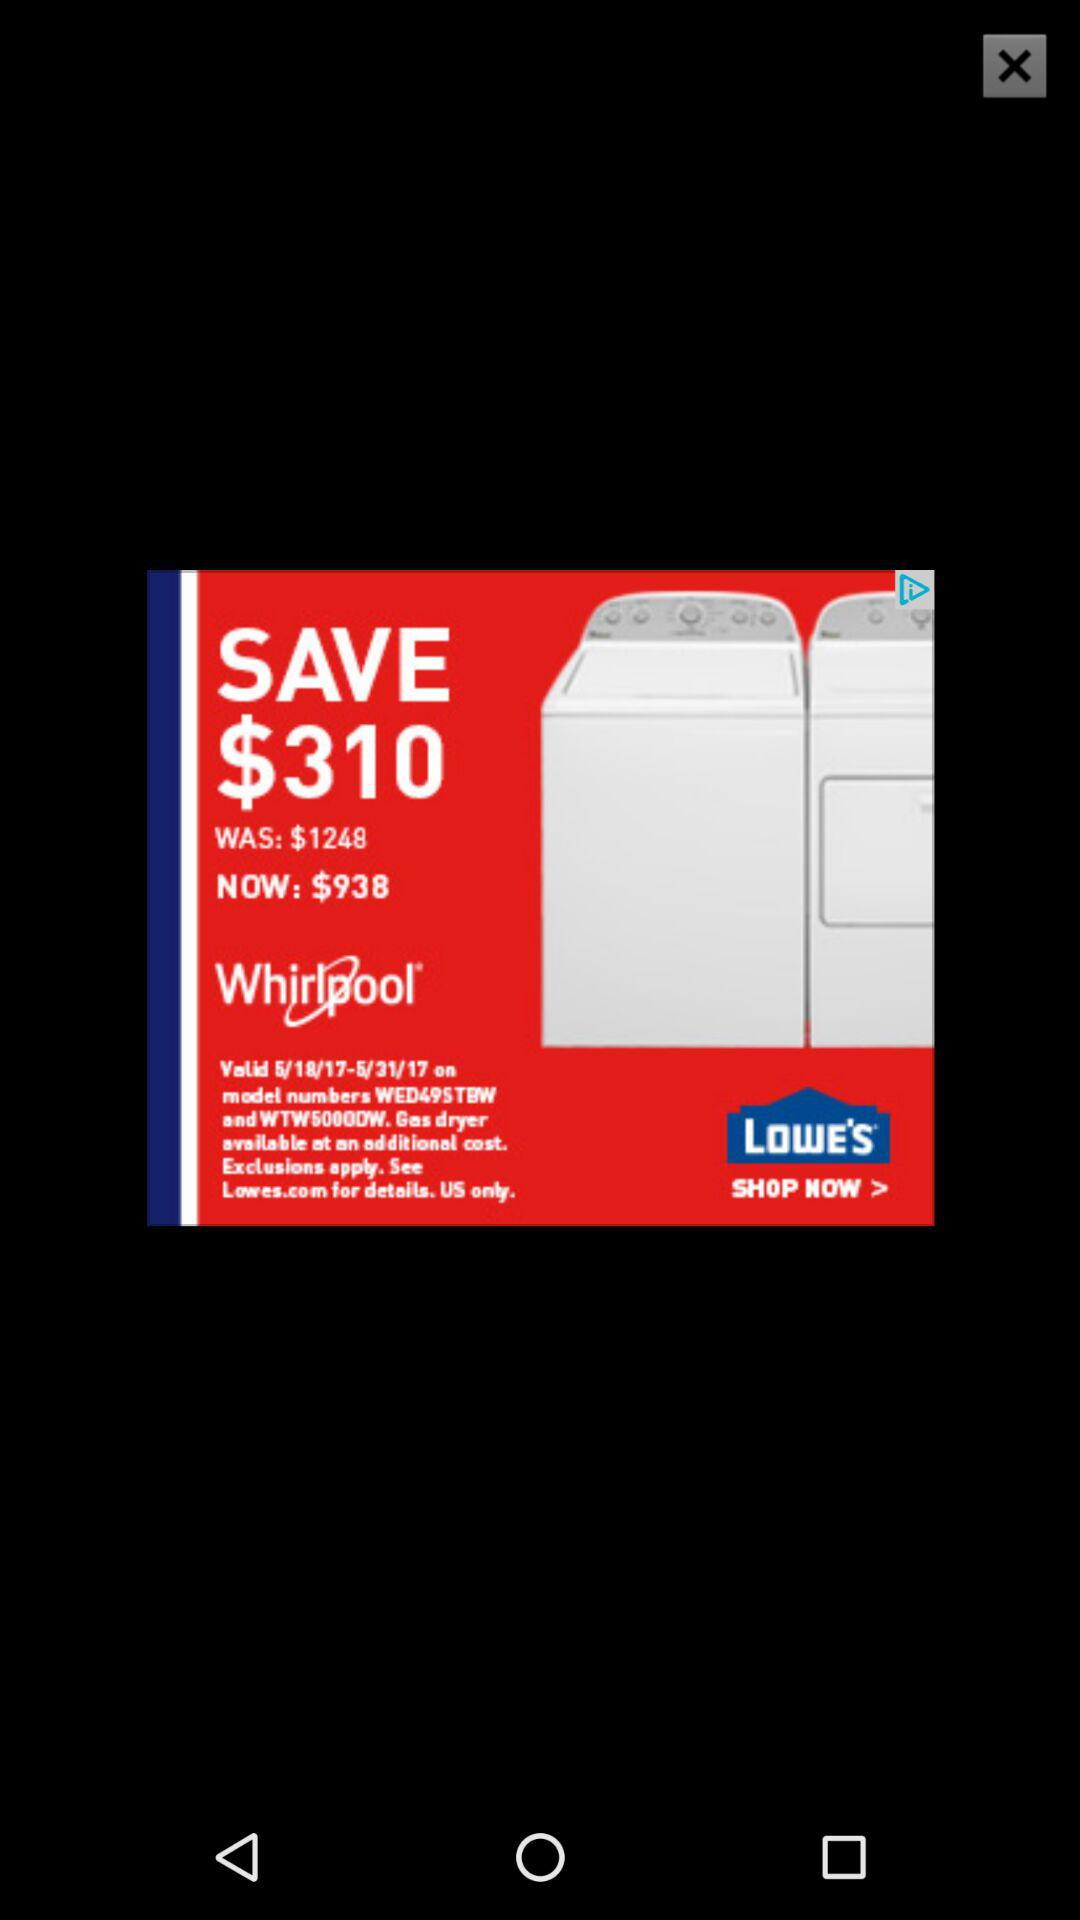How much money do I save by buying this item at the sale price?
Answer the question using a single word or phrase. $310 